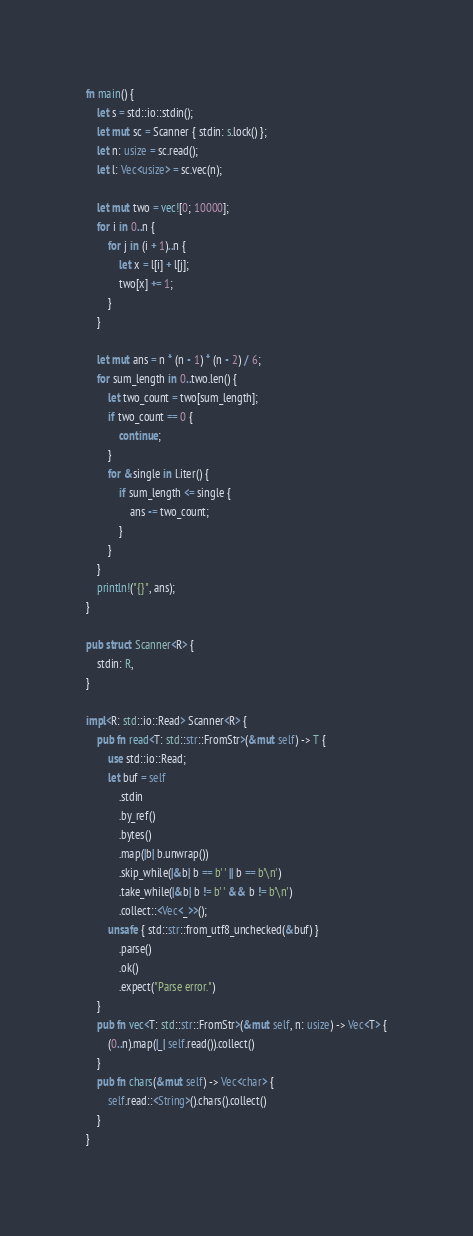Convert code to text. <code><loc_0><loc_0><loc_500><loc_500><_Rust_>fn main() {
    let s = std::io::stdin();
    let mut sc = Scanner { stdin: s.lock() };
    let n: usize = sc.read();
    let l: Vec<usize> = sc.vec(n);

    let mut two = vec![0; 10000];
    for i in 0..n {
        for j in (i + 1)..n {
            let x = l[i] + l[j];
            two[x] += 1;
        }
    }

    let mut ans = n * (n - 1) * (n - 2) / 6;
    for sum_length in 0..two.len() {
        let two_count = two[sum_length];
        if two_count == 0 {
            continue;
        }
        for &single in l.iter() {
            if sum_length <= single {
                ans -= two_count;
            }
        }
    }
    println!("{}", ans);
}

pub struct Scanner<R> {
    stdin: R,
}

impl<R: std::io::Read> Scanner<R> {
    pub fn read<T: std::str::FromStr>(&mut self) -> T {
        use std::io::Read;
        let buf = self
            .stdin
            .by_ref()
            .bytes()
            .map(|b| b.unwrap())
            .skip_while(|&b| b == b' ' || b == b'\n')
            .take_while(|&b| b != b' ' && b != b'\n')
            .collect::<Vec<_>>();
        unsafe { std::str::from_utf8_unchecked(&buf) }
            .parse()
            .ok()
            .expect("Parse error.")
    }
    pub fn vec<T: std::str::FromStr>(&mut self, n: usize) -> Vec<T> {
        (0..n).map(|_| self.read()).collect()
    }
    pub fn chars(&mut self) -> Vec<char> {
        self.read::<String>().chars().collect()
    }
}
</code> 